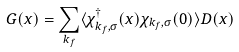<formula> <loc_0><loc_0><loc_500><loc_500>G ( x ) = \sum _ { { k } _ { f } } \langle \chi _ { { k } _ { f } , \sigma } ^ { \dagger } ( x ) \chi _ { { k } _ { f } , \sigma } ( 0 ) \rangle D ( x )</formula> 